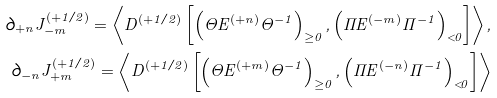Convert formula to latex. <formula><loc_0><loc_0><loc_500><loc_500>\partial _ { + n } J _ { - m } ^ { ( + 1 / 2 ) } = \left \langle D ^ { ( + 1 / 2 ) } \left [ \left ( \Theta E ^ { ( + n ) } \Theta ^ { - 1 } \right ) _ { \geq 0 } , \left ( \Pi E ^ { ( - m ) } \Pi ^ { - 1 } \right ) _ { < 0 } \right ] \right \rangle , \\ \partial _ { - n } J _ { + m } ^ { ( + 1 / 2 ) } = \left \langle D ^ { ( + 1 / 2 ) } \left [ \left ( \Theta E ^ { ( + m ) } \Theta ^ { - 1 } \right ) _ { \geq 0 } , \left ( \Pi E ^ { ( - n ) } \Pi ^ { - 1 } \right ) _ { < 0 } \right ] \right \rangle</formula> 